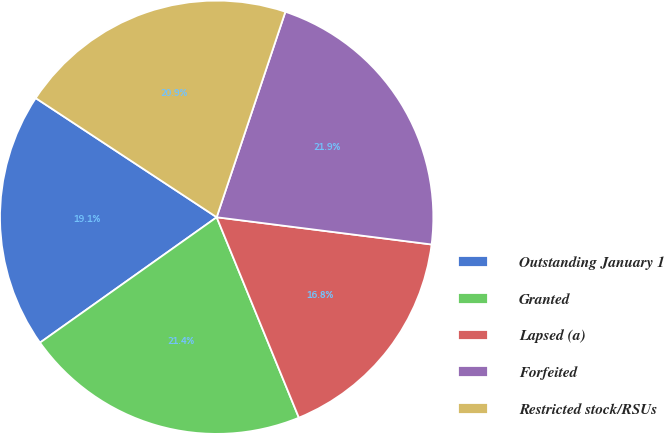<chart> <loc_0><loc_0><loc_500><loc_500><pie_chart><fcel>Outstanding January 1<fcel>Granted<fcel>Lapsed (a)<fcel>Forfeited<fcel>Restricted stock/RSUs<nl><fcel>19.09%<fcel>21.37%<fcel>16.8%<fcel>21.87%<fcel>20.87%<nl></chart> 